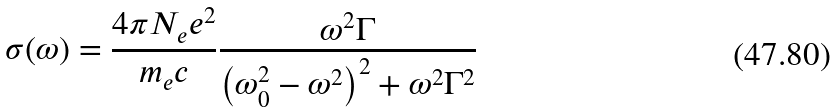<formula> <loc_0><loc_0><loc_500><loc_500>\sigma ( \omega ) = \frac { 4 \pi N _ { e } e ^ { 2 } } { m _ { e } c } \frac { \omega ^ { 2 } \Gamma } { \left ( \omega _ { 0 } ^ { 2 } - \omega ^ { 2 } \right ) ^ { 2 } + \omega ^ { 2 } \Gamma ^ { 2 } }</formula> 